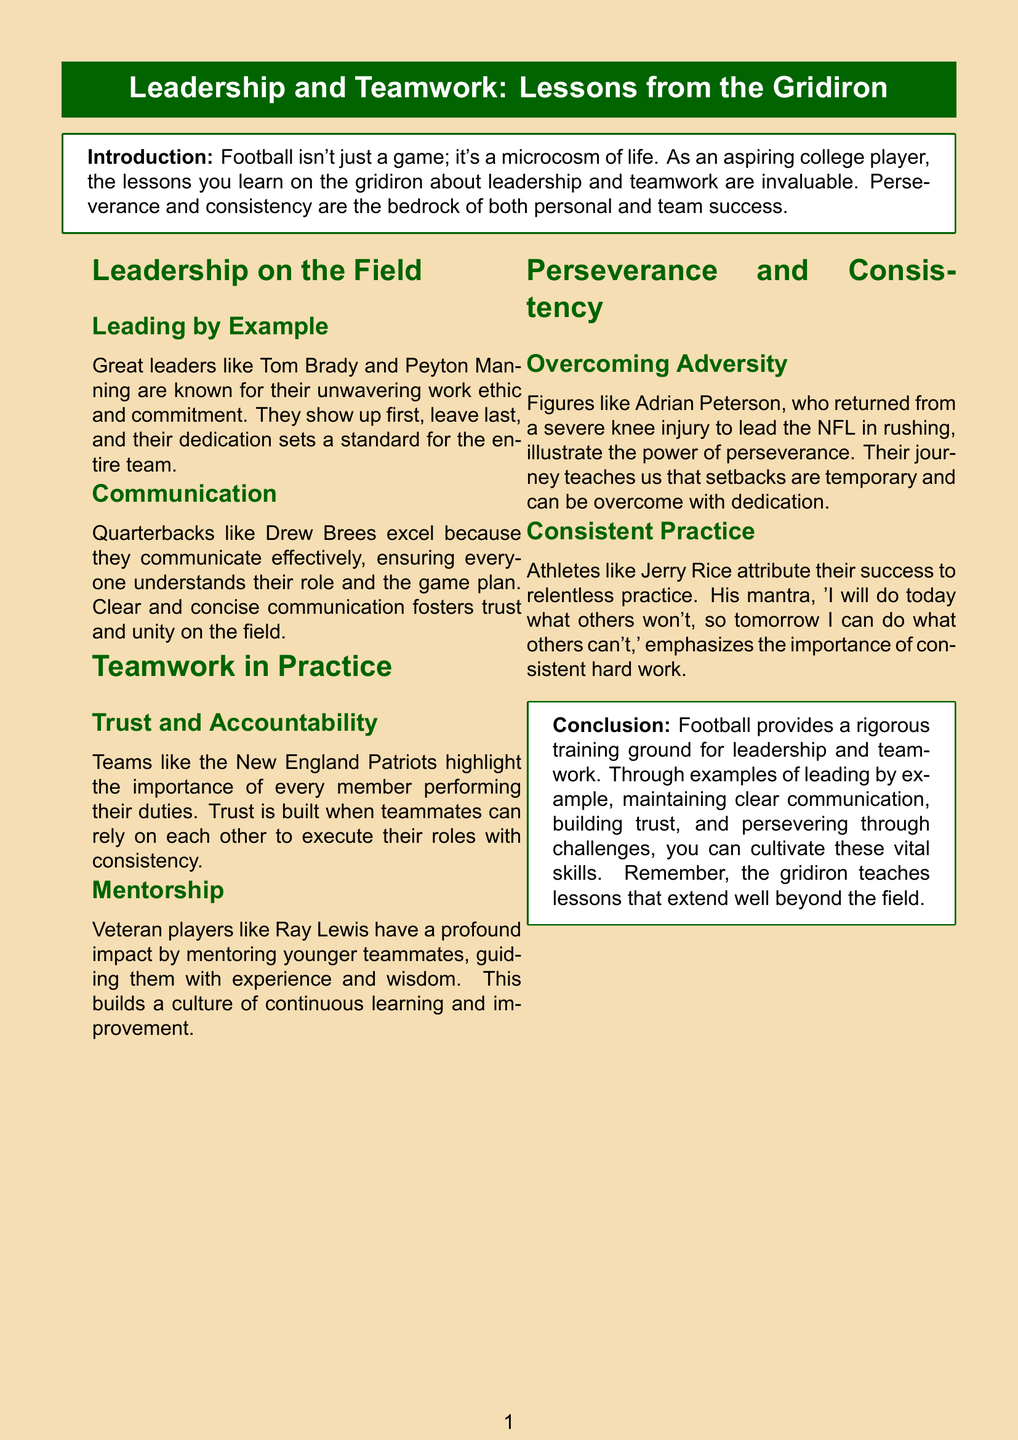What are two qualities of great leaders mentioned? The document states that great leaders are known for their unwavering work ethic and commitment.
Answer: work ethic, commitment Which player returned from a severe knee injury? The document highlights Adrian Peterson's return from injury as an example of perseverance.
Answer: Adrian Peterson What does Jerry Rice's mantra emphasize? Jerry Rice's mantra emphasizes the importance of consistent hard work.
Answer: consistent hard work Who is highlighted for effective communication on the field? The document mentions Drew Brees as an example of a player who excels in communication.
Answer: Drew Brees What culture does Ray Lewis help build through mentorship? Ray Lewis builds a culture of continuous learning and improvement through mentorship.
Answer: continuous learning and improvement Which team is mentioned for trust and accountability? The New England Patriots are highlighted in the document for this aspect.
Answer: New England Patriots What type of practice does Jerry Rice attribute his success to? The document states that Jerry Rice attributes his success to relentless practice.
Answer: relentless practice What is the main takeaway from the conclusion? The conclusion emphasizes that football teaches vital skills that extend beyond the field.
Answer: vital skills beyond the field 